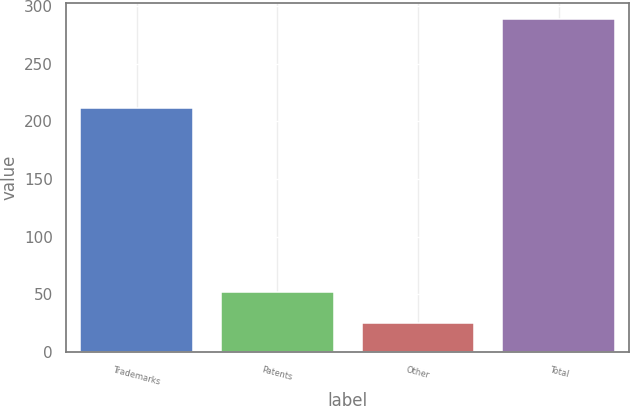<chart> <loc_0><loc_0><loc_500><loc_500><bar_chart><fcel>Trademarks<fcel>Patents<fcel>Other<fcel>Total<nl><fcel>211.7<fcel>52<fcel>24.9<fcel>288.6<nl></chart> 